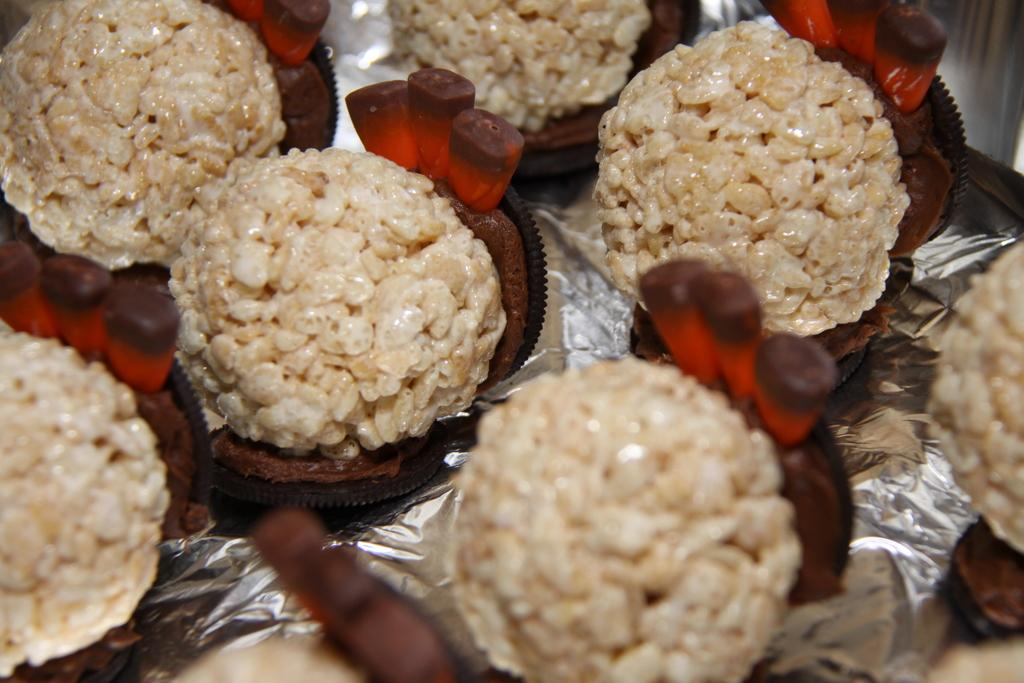What can be seen in the image? There are food items in the image. How are the food items arranged or presented? The food items are placed on foil. What type of bushes can be seen growing in the image? There are no bushes present in the image; it only features food items placed on foil. What type of test is being conducted in the image? There is no test being conducted in the image; it only features food items placed on foil. 